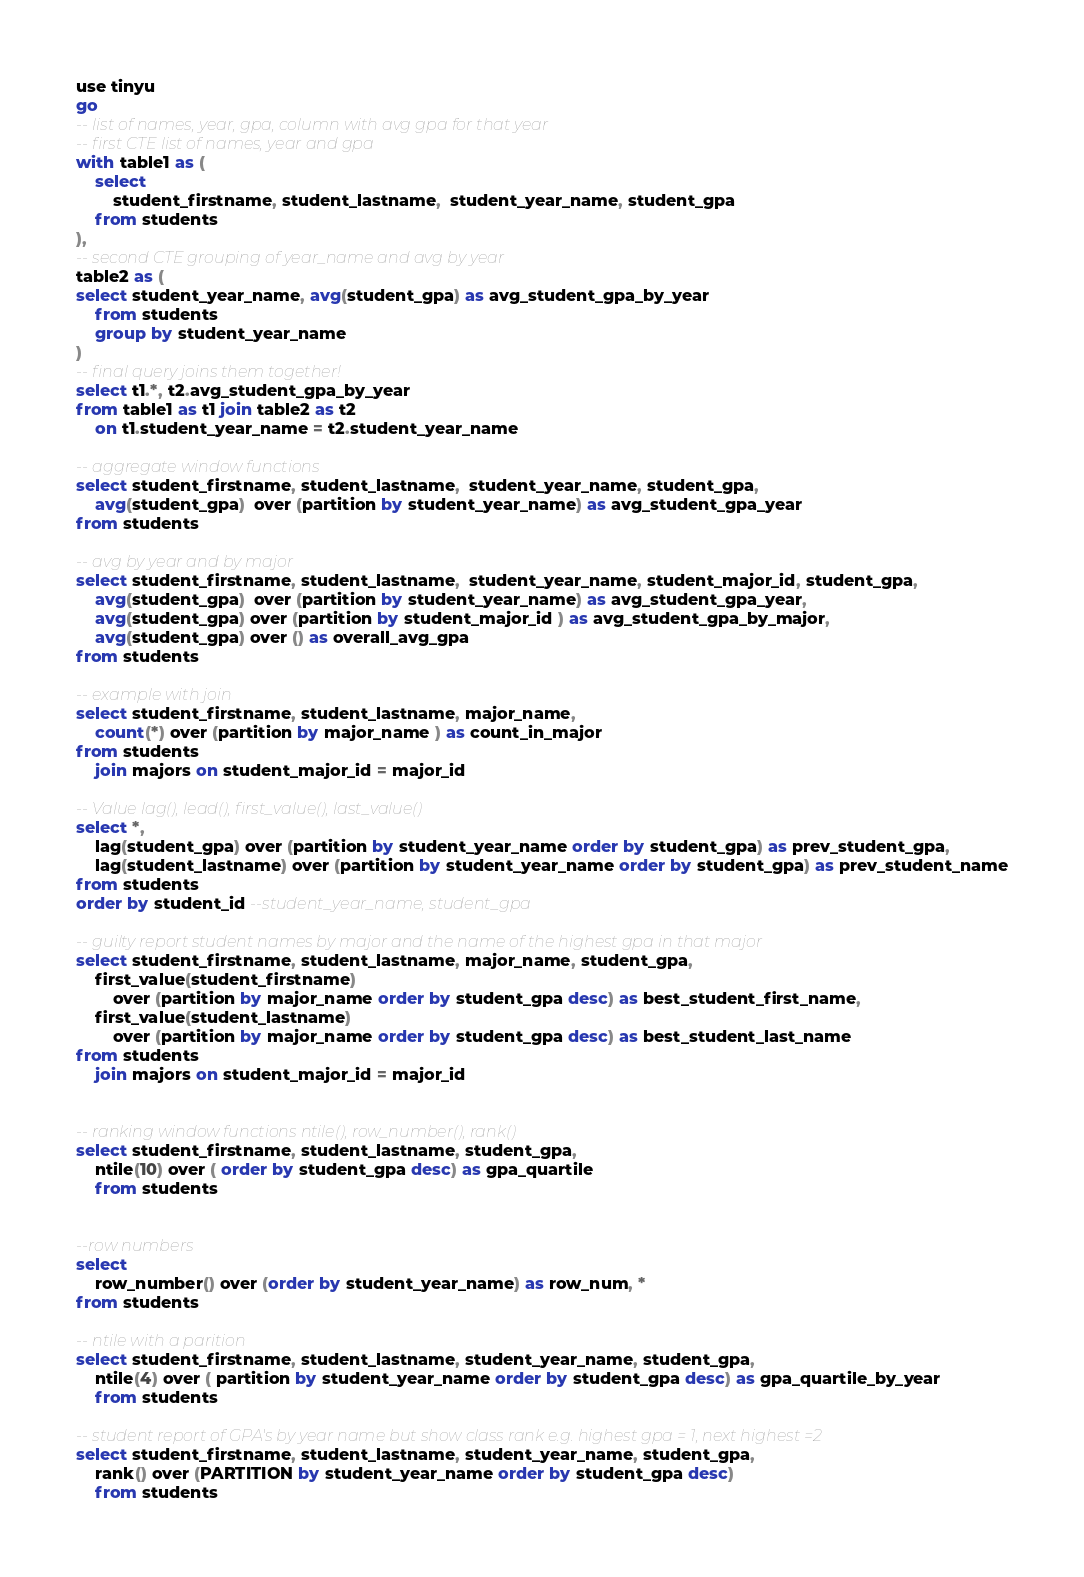Convert code to text. <code><loc_0><loc_0><loc_500><loc_500><_SQL_>use tinyu
go
-- list of names, year, gpa, column with avg gpa for that year
-- first CTE list of names, year and gpa
with table1 as (
    select 
        student_firstname, student_lastname,  student_year_name, student_gpa
    from students
),
-- second CTE grouping of year_name and avg by year
table2 as (
select student_year_name, avg(student_gpa) as avg_student_gpa_by_year
    from students
    group by student_year_name
)
-- final query joins them together!
select t1.*, t2.avg_student_gpa_by_year
from table1 as t1 join table2 as t2 
    on t1.student_year_name = t2.student_year_name

-- aggregate window functions
select student_firstname, student_lastname,  student_year_name, student_gpa,
    avg(student_gpa)  over (partition by student_year_name) as avg_student_gpa_year
from students

-- avg by year and by major
select student_firstname, student_lastname,  student_year_name, student_major_id, student_gpa,
    avg(student_gpa)  over (partition by student_year_name) as avg_student_gpa_year,
    avg(student_gpa) over (partition by student_major_id ) as avg_student_gpa_by_major,
    avg(student_gpa) over () as overall_avg_gpa
from students

-- example with join
select student_firstname, student_lastname, major_name,
    count(*) over (partition by major_name ) as count_in_major
from students 
    join majors on student_major_id = major_id

-- Value lag(), lead(), first_value(), last_value()
select *,
    lag(student_gpa) over (partition by student_year_name order by student_gpa) as prev_student_gpa,
    lag(student_lastname) over (partition by student_year_name order by student_gpa) as prev_student_name
from students
order by student_id --student_year_name, student_gpa

-- guilty report student names by major and the name of the highest gpa in that major
select student_firstname, student_lastname, major_name, student_gpa,
    first_value(student_firstname) 
        over (partition by major_name order by student_gpa desc) as best_student_first_name,
    first_value(student_lastname) 
        over (partition by major_name order by student_gpa desc) as best_student_last_name
from students 
    join majors on student_major_id = major_id


-- ranking window functions ntile(), row_number(), rank()
select student_firstname, student_lastname, student_gpa,
    ntile(10) over ( order by student_gpa desc) as gpa_quartile
    from students


--row numbers
select 
    row_number() over (order by student_year_name) as row_num, * 
from students

-- ntile with a parition
select student_firstname, student_lastname, student_year_name, student_gpa,
    ntile(4) over ( partition by student_year_name order by student_gpa desc) as gpa_quartile_by_year
    from students

-- student report of GPA's by year name but show class rank e.g. highest gpa = 1, next highest =2 
select student_firstname, student_lastname, student_year_name, student_gpa,
    rank() over (PARTITION by student_year_name order by student_gpa desc)
    from students</code> 